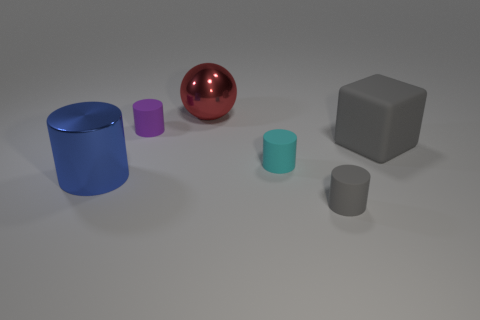Add 1 tiny cylinders. How many objects exist? 7 Subtract all cyan cylinders. How many cylinders are left? 3 Subtract all small cyan matte cylinders. How many cylinders are left? 3 Subtract all red cylinders. Subtract all blue balls. How many cylinders are left? 4 Subtract all spheres. How many objects are left? 5 Subtract 0 yellow cylinders. How many objects are left? 6 Subtract all large gray objects. Subtract all blue things. How many objects are left? 4 Add 2 large red metal balls. How many large red metal balls are left? 3 Add 4 yellow rubber spheres. How many yellow rubber spheres exist? 4 